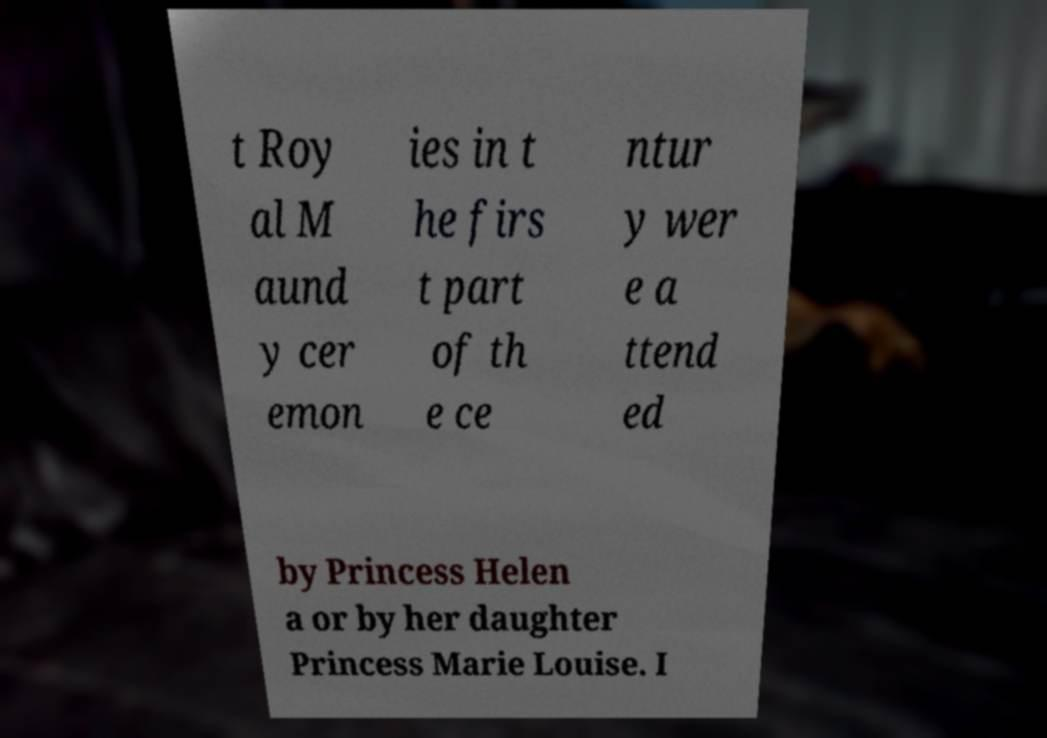There's text embedded in this image that I need extracted. Can you transcribe it verbatim? t Roy al M aund y cer emon ies in t he firs t part of th e ce ntur y wer e a ttend ed by Princess Helen a or by her daughter Princess Marie Louise. I 